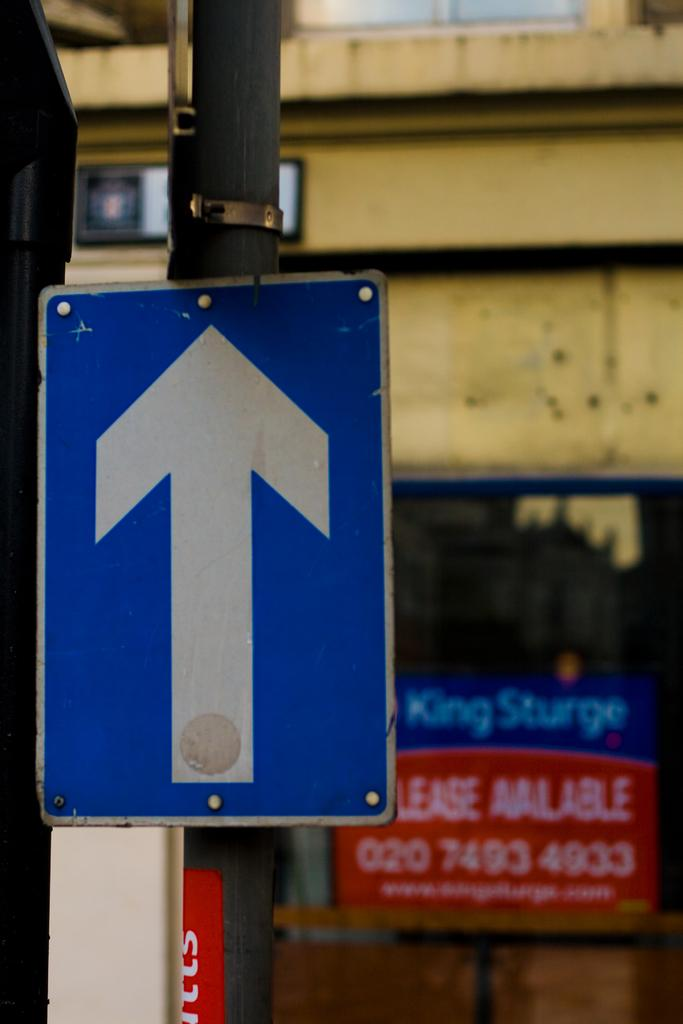<image>
Summarize the visual content of the image. Behind the street arrow sign, a sign is in a window that indicates there is a lease available. 